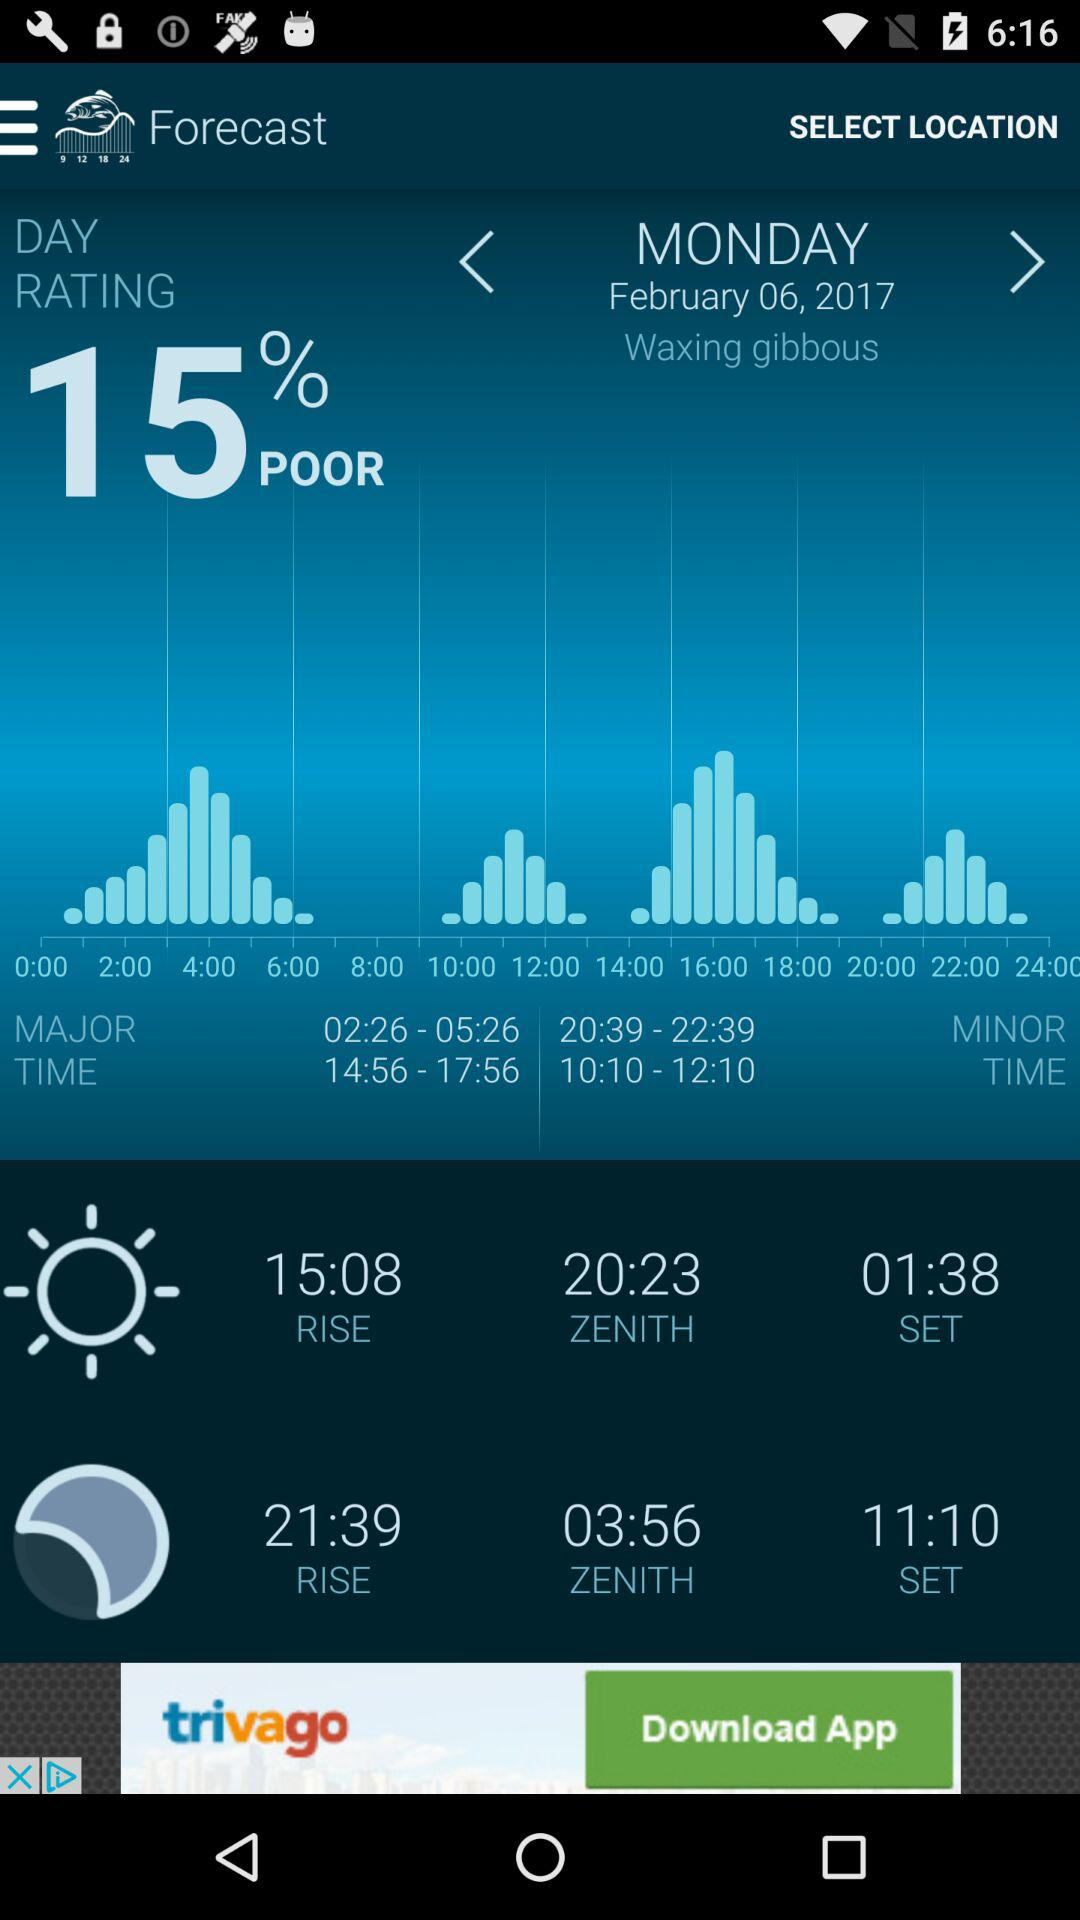At what time does the moon rise? The moon rises at 21:39. 